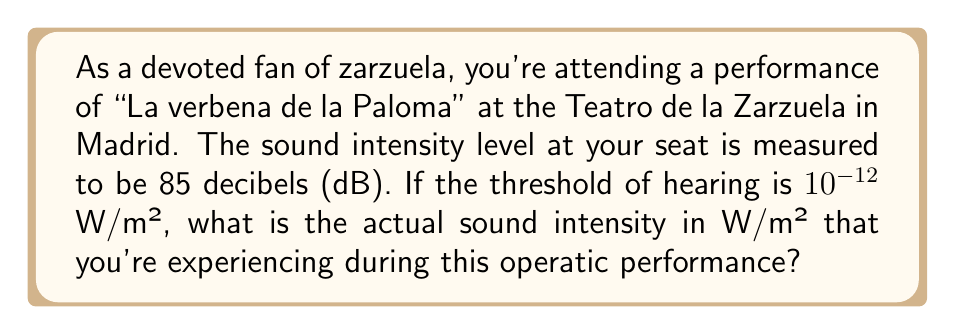Help me with this question. To solve this problem, we need to use the formula for sound intensity level in decibels:

$$ \beta = 10 \log_{10}\left(\frac{I}{I_0}\right) $$

Where:
$\beta$ = sound intensity level in decibels (dB)
$I$ = sound intensity in W/m²
$I_0$ = threshold of hearing, which is $10^{-12}$ W/m²

We're given:
$\beta = 85$ dB
$I_0 = 10^{-12}$ W/m²

We need to solve for $I$. Let's substitute the known values into the equation:

$$ 85 = 10 \log_{10}\left(\frac{I}{10^{-12}}\right) $$

Now, let's solve for $I$:

1) Divide both sides by 10:
   $$ 8.5 = \log_{10}\left(\frac{I}{10^{-12}}\right) $$

2) Apply $10^x$ to both sides:
   $$ 10^{8.5} = \frac{I}{10^{-12}} $$

3) Multiply both sides by $10^{-12}$:
   $$ I = 10^{8.5} \cdot 10^{-12} = 10^{-3.5} $$

4) Calculate the final value:
   $$ I = 10^{-3.5} \approx 3.16 \times 10^{-4} \text{ W/m²} $$
Answer: The actual sound intensity you're experiencing during the zarzuela performance is approximately $3.16 \times 10^{-4}$ W/m². 